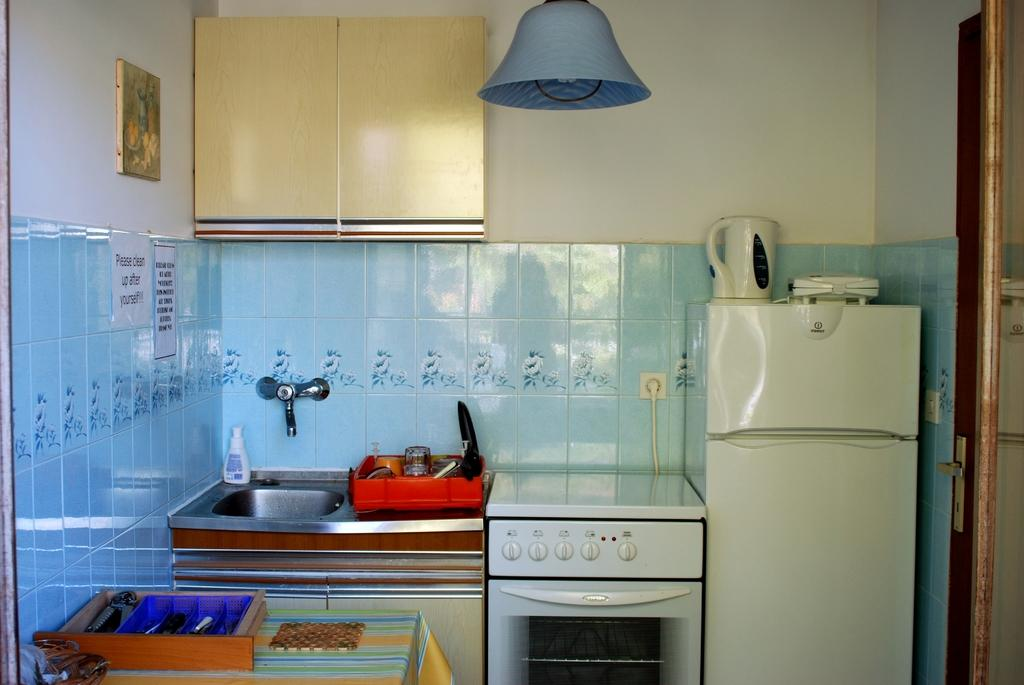<image>
Present a compact description of the photo's key features. A kitchen with signs to the left of the fridge stating to clean up after yourself 